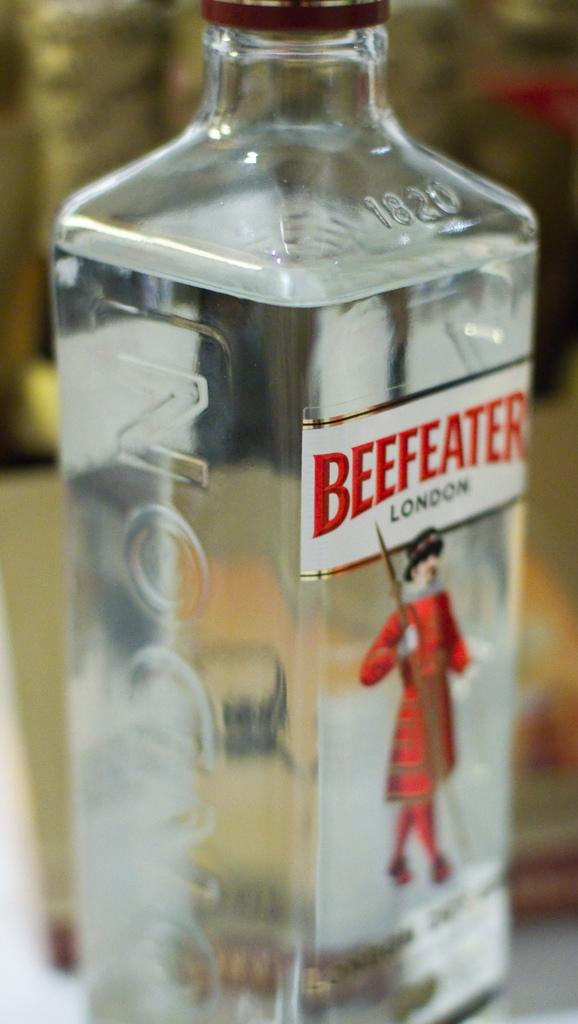What is the main object in the image? There is a beer bottle in the image. What is depicted on the beer bottle? There is a statue of a man on the beer bottle. What is the man in the statue doing? The man is standing in the statue. What is the man holding in the statue? The man is holding a sword in his hand in the statue. How many bridges can be seen in the image? There are no bridges present in the image. What type of line is used to draw the man in the statue? The image is not a drawing, so there is no line used to depict the man in the statue. 